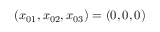Convert formula to latex. <formula><loc_0><loc_0><loc_500><loc_500>( x _ { 0 1 } , x _ { 0 2 } , x _ { 0 3 } ) = ( 0 , 0 , 0 )</formula> 